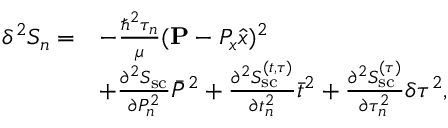<formula> <loc_0><loc_0><loc_500><loc_500>\begin{array} { r l } { \delta ^ { 2 } S _ { n } = } & { - \frac { \hbar { ^ } { 2 } \tau _ { n } } { \mu } ( { P } - P _ { x } \hat { x } ) ^ { 2 } } \\ & { + \frac { \partial ^ { 2 } S _ { s c } } { \partial P _ { n } ^ { 2 } } \bar { P } ^ { 2 } + \frac { \partial ^ { 2 } S _ { s c } ^ { ( t , \tau ) } } { \partial t _ { n } ^ { 2 } } \bar { t } ^ { 2 } + \frac { \partial ^ { 2 } S _ { s c } ^ { ( \tau ) } } { \partial \tau _ { n } ^ { 2 } } \delta \tau ^ { 2 } , } \end{array}</formula> 